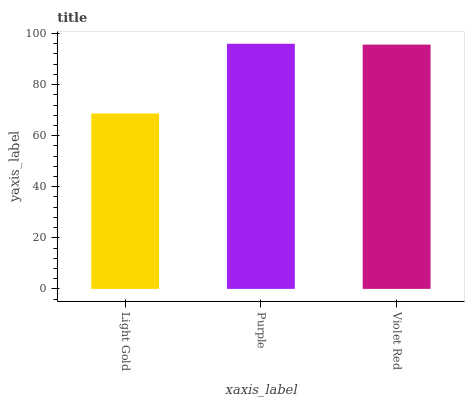Is Light Gold the minimum?
Answer yes or no. Yes. Is Purple the maximum?
Answer yes or no. Yes. Is Violet Red the minimum?
Answer yes or no. No. Is Violet Red the maximum?
Answer yes or no. No. Is Purple greater than Violet Red?
Answer yes or no. Yes. Is Violet Red less than Purple?
Answer yes or no. Yes. Is Violet Red greater than Purple?
Answer yes or no. No. Is Purple less than Violet Red?
Answer yes or no. No. Is Violet Red the high median?
Answer yes or no. Yes. Is Violet Red the low median?
Answer yes or no. Yes. Is Light Gold the high median?
Answer yes or no. No. Is Light Gold the low median?
Answer yes or no. No. 